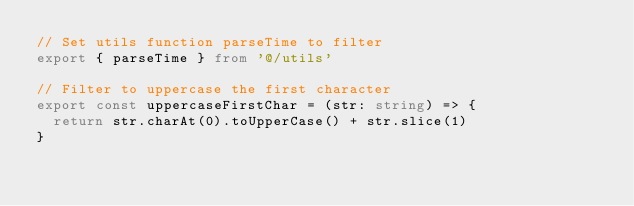Convert code to text. <code><loc_0><loc_0><loc_500><loc_500><_TypeScript_>// Set utils function parseTime to filter
export { parseTime } from '@/utils'

// Filter to uppercase the first character
export const uppercaseFirstChar = (str: string) => {
  return str.charAt(0).toUpperCase() + str.slice(1)
}
</code> 